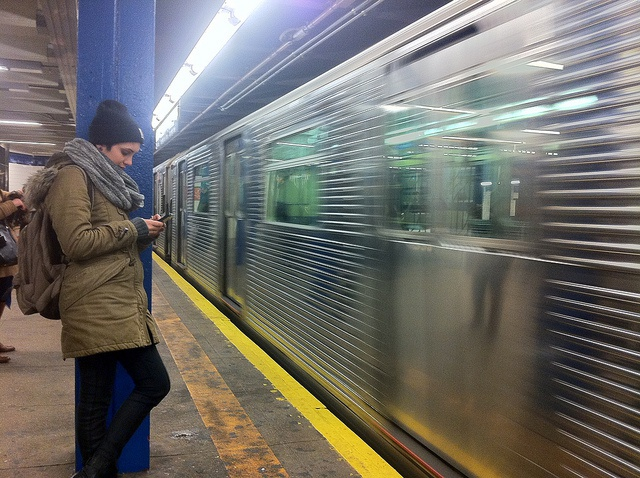Describe the objects in this image and their specific colors. I can see train in gray, darkgray, and black tones, people in gray and black tones, backpack in gray, black, and maroon tones, people in gray, black, and maroon tones, and people in gray, teal, purple, black, and darkgray tones in this image. 